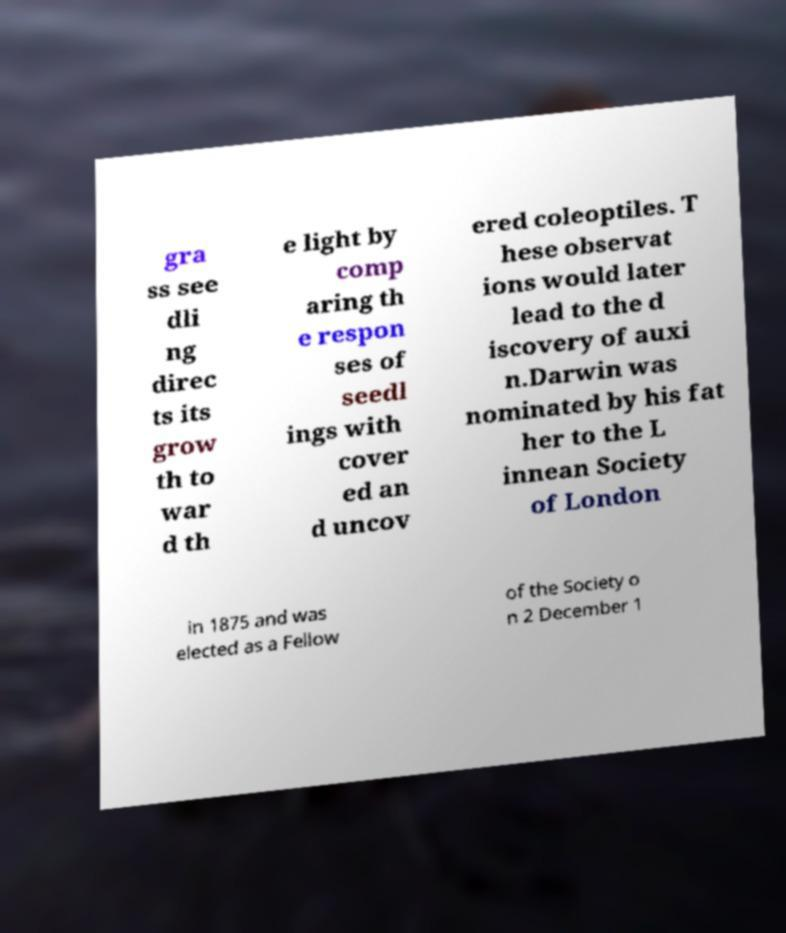Can you accurately transcribe the text from the provided image for me? gra ss see dli ng direc ts its grow th to war d th e light by comp aring th e respon ses of seedl ings with cover ed an d uncov ered coleoptiles. T hese observat ions would later lead to the d iscovery of auxi n.Darwin was nominated by his fat her to the L innean Society of London in 1875 and was elected as a Fellow of the Society o n 2 December 1 